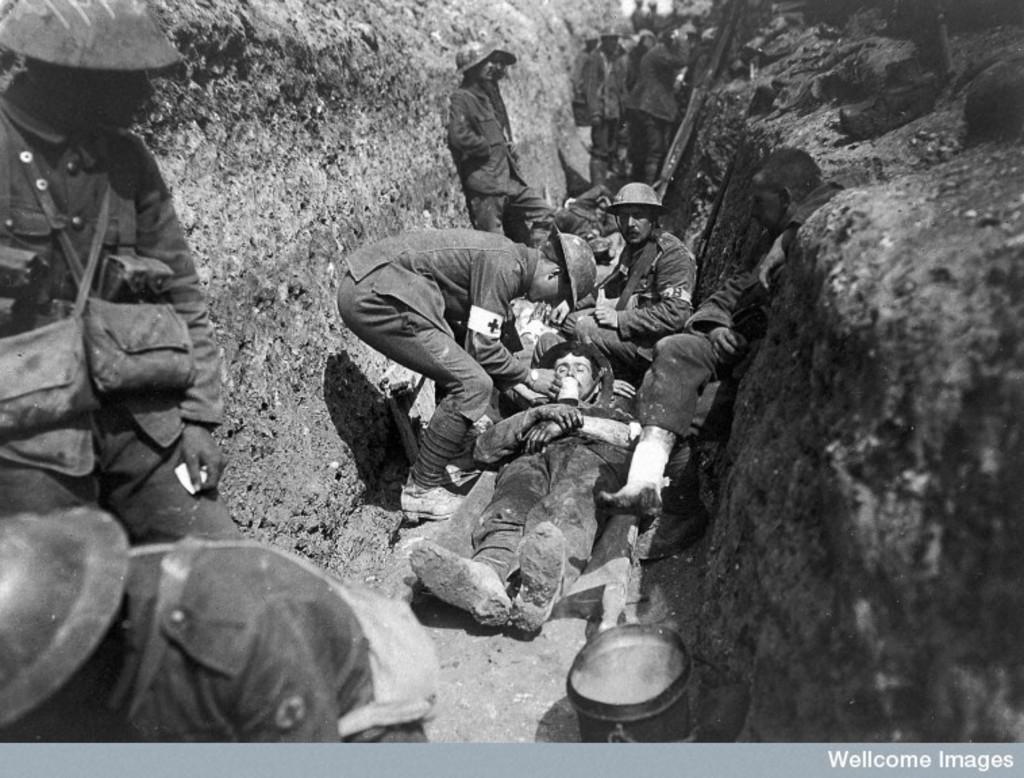How would you summarize this image in a sentence or two? It looks like a black and white picture. We can see there are some people standing, a person is lying and another person is sitting. On the left and right side of the people there are walls. 